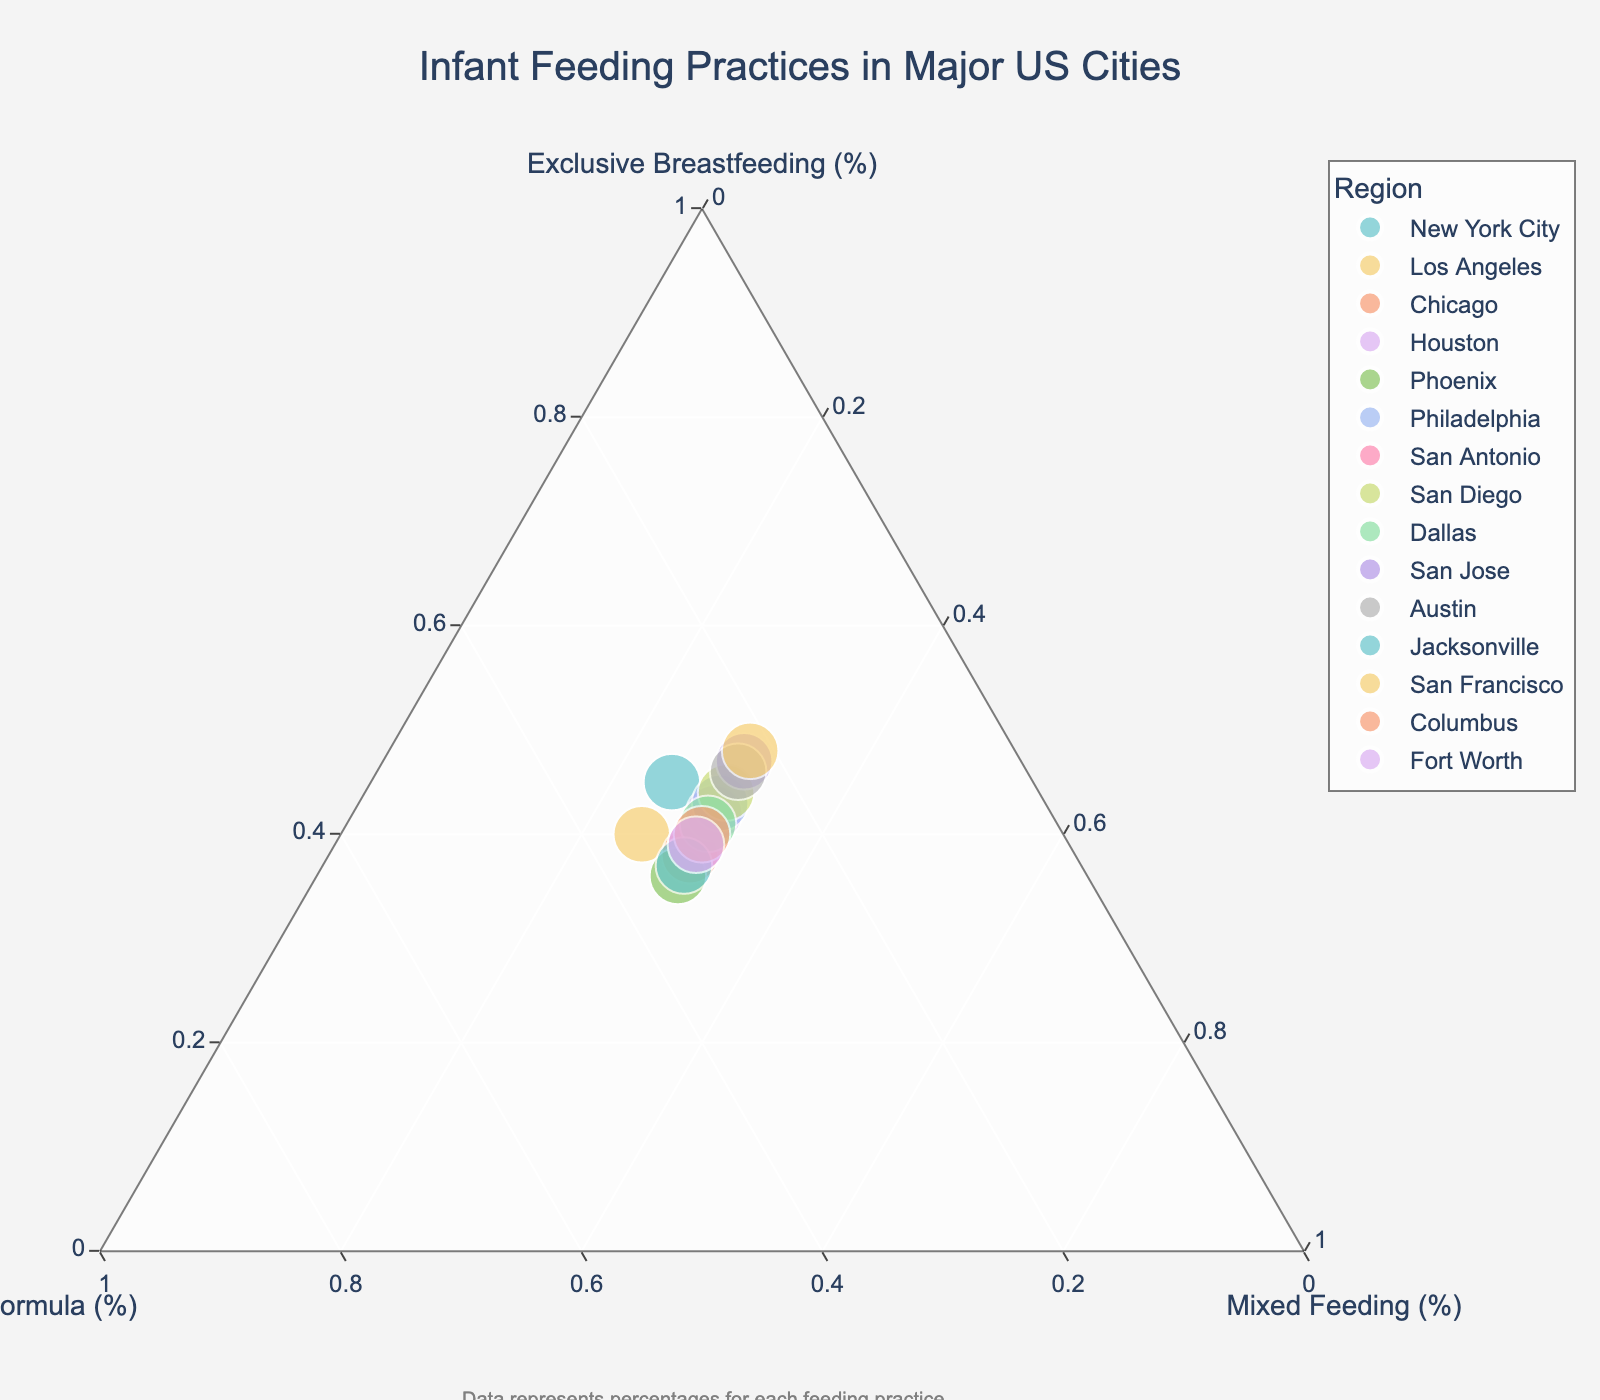What is the title of the plot? The title is often located at the top of the plot and provides a summary of what the plot represents. In this case, it is "Infant Feeding Practices in Major US Cities".
Answer: Infant Feeding Practices in Major US Cities How many regions are represented in the plot? Each region corresponds to a unique data point in the plot. By counting the data points or checking the data provided, you will find there are 15 regions.
Answer: 15 Which city has the highest percentage of exclusive breastfeeding? Locate the data point that is closest to the vertex labeled "Exclusive Breastfeeding". According to the data, San Francisco has the highest percentage at 48%.
Answer: San Francisco Is the percentage of mixed feeding the same for all cities? Check the data points’ distribution relative to the "Mixed Feeding" vertex. Here, all cities have exactly 30% of mixed feeding.
Answer: Yes What is the average percentage of formula feeding across all cities? Sum the percentages of formula feeding for all cities and then divide by the number of cities. (30+35+32+28+34+27+31+26+29+23+24+33+22+30+31) / 15 = 29.53
Answer: 29.53% Compare the exclusive breastfeeding percentage between New York City and Los Angeles. Locate the data points for both cities and check their exclusive breastfeeding percentages: New York City has 45% and Los Angeles has 40%. Therefore, New York City is higher.
Answer: New York City Which city has the lowest percentage of formula feeding? Find the data point closest to the "Formula" vertex with the smallest percentage. According to the data, San Francisco has the lowest at 22%.
Answer: San Francisco What is the difference in exclusive breastfeeding between the highest and lowest cities? The highest is San Francisco at 48% and the lowest is Phoenix at 36%. The difference is 48% - 36% = 12%.
Answer: 12% Are there any cities with an exclusive breastfeeding percentage greater than 45%? Review the data points above 45% around the "Exclusive Breastfeeding" vertex. San Francisco, San Jose, and Austin are above 45%.
Answer: Yes Which three cities have the highest overall percentages of exclusive breastfeeding? Rank cities by exclusive breastfeeding percentages from the data. The top three are San Francisco (48%), San Jose (47%), and Austin (46%).
Answer: San Francisco, San Jose, Austin 